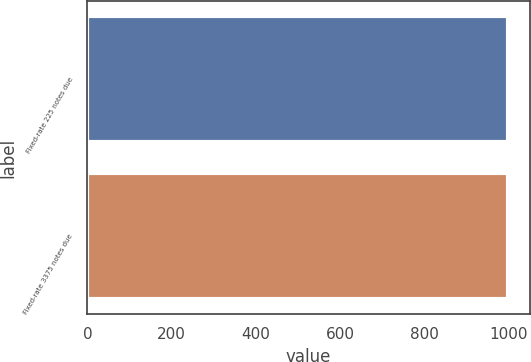Convert chart. <chart><loc_0><loc_0><loc_500><loc_500><bar_chart><fcel>Fixed-rate 225 notes due<fcel>Fixed-rate 3375 notes due<nl><fcel>1000<fcel>1000.1<nl></chart> 